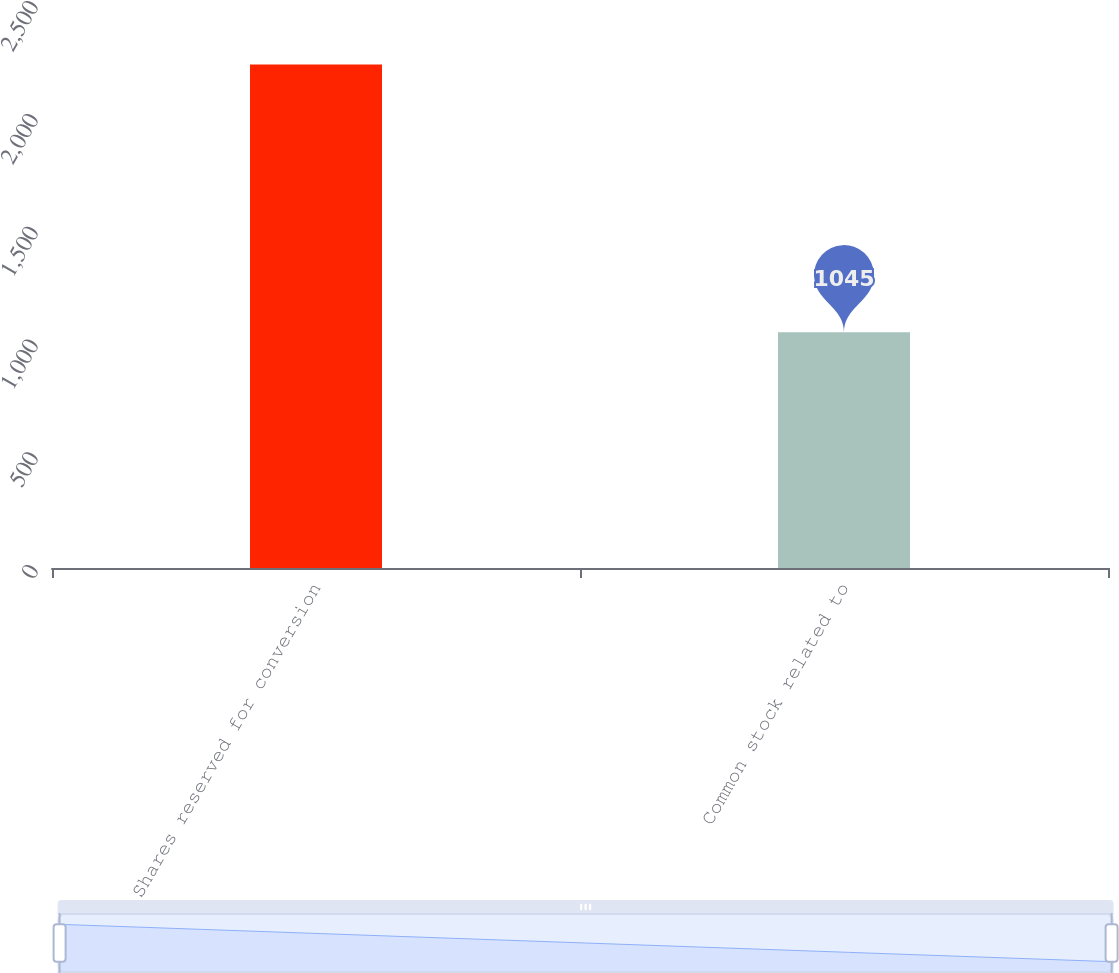<chart> <loc_0><loc_0><loc_500><loc_500><bar_chart><fcel>Shares reserved for conversion<fcel>Common stock related to<nl><fcel>2232<fcel>1045<nl></chart> 